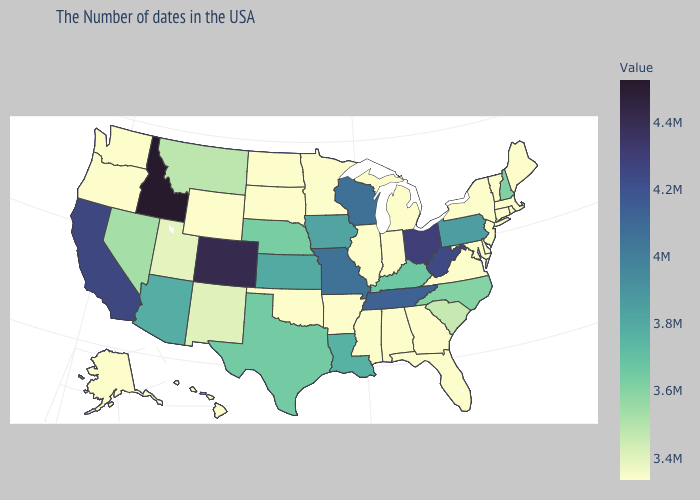Which states have the lowest value in the USA?
Keep it brief. Maine, Massachusetts, Rhode Island, Vermont, Connecticut, New York, New Jersey, Delaware, Maryland, Virginia, Florida, Georgia, Michigan, Indiana, Alabama, Illinois, Mississippi, Arkansas, Minnesota, Oklahoma, South Dakota, North Dakota, Wyoming, Washington, Oregon, Alaska, Hawaii. Which states have the lowest value in the USA?
Give a very brief answer. Maine, Massachusetts, Rhode Island, Vermont, Connecticut, New York, New Jersey, Delaware, Maryland, Virginia, Florida, Georgia, Michigan, Indiana, Alabama, Illinois, Mississippi, Arkansas, Minnesota, Oklahoma, South Dakota, North Dakota, Wyoming, Washington, Oregon, Alaska, Hawaii. Is the legend a continuous bar?
Answer briefly. Yes. Does Ohio have a lower value than Idaho?
Write a very short answer. Yes. Does Oregon have the lowest value in the USA?
Quick response, please. Yes. Does Washington have the lowest value in the USA?
Answer briefly. Yes. 